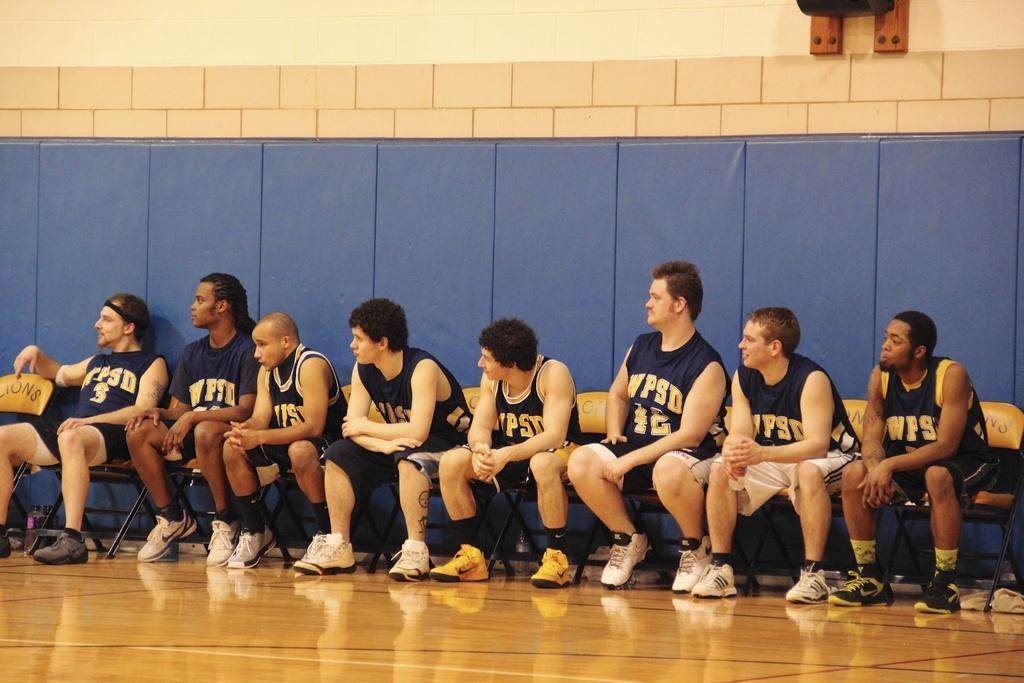Can you describe this image briefly? In this image, we can see a group of people are sitting on the chairs. At the bottom, we can see a floor. Background there is a wall. Here we can see wooden object and black color thing. 